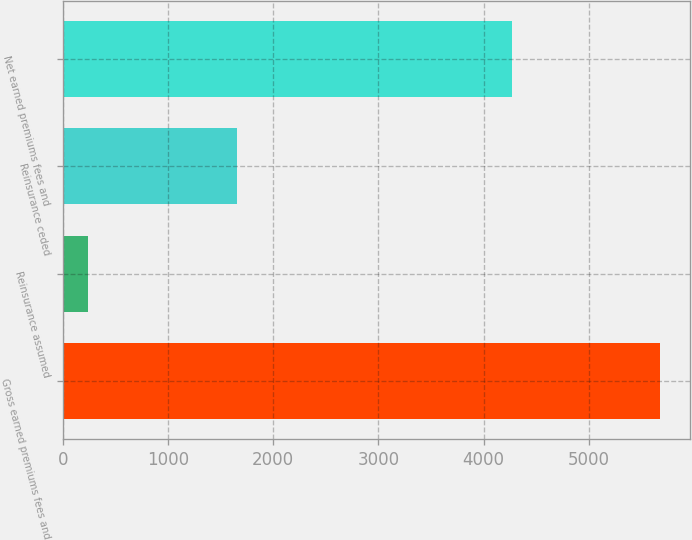<chart> <loc_0><loc_0><loc_500><loc_500><bar_chart><fcel>Gross earned premiums fees and<fcel>Reinsurance assumed<fcel>Reinsurance ceded<fcel>Net earned premiums fees and<nl><fcel>5682<fcel>236<fcel>1651<fcel>4267<nl></chart> 